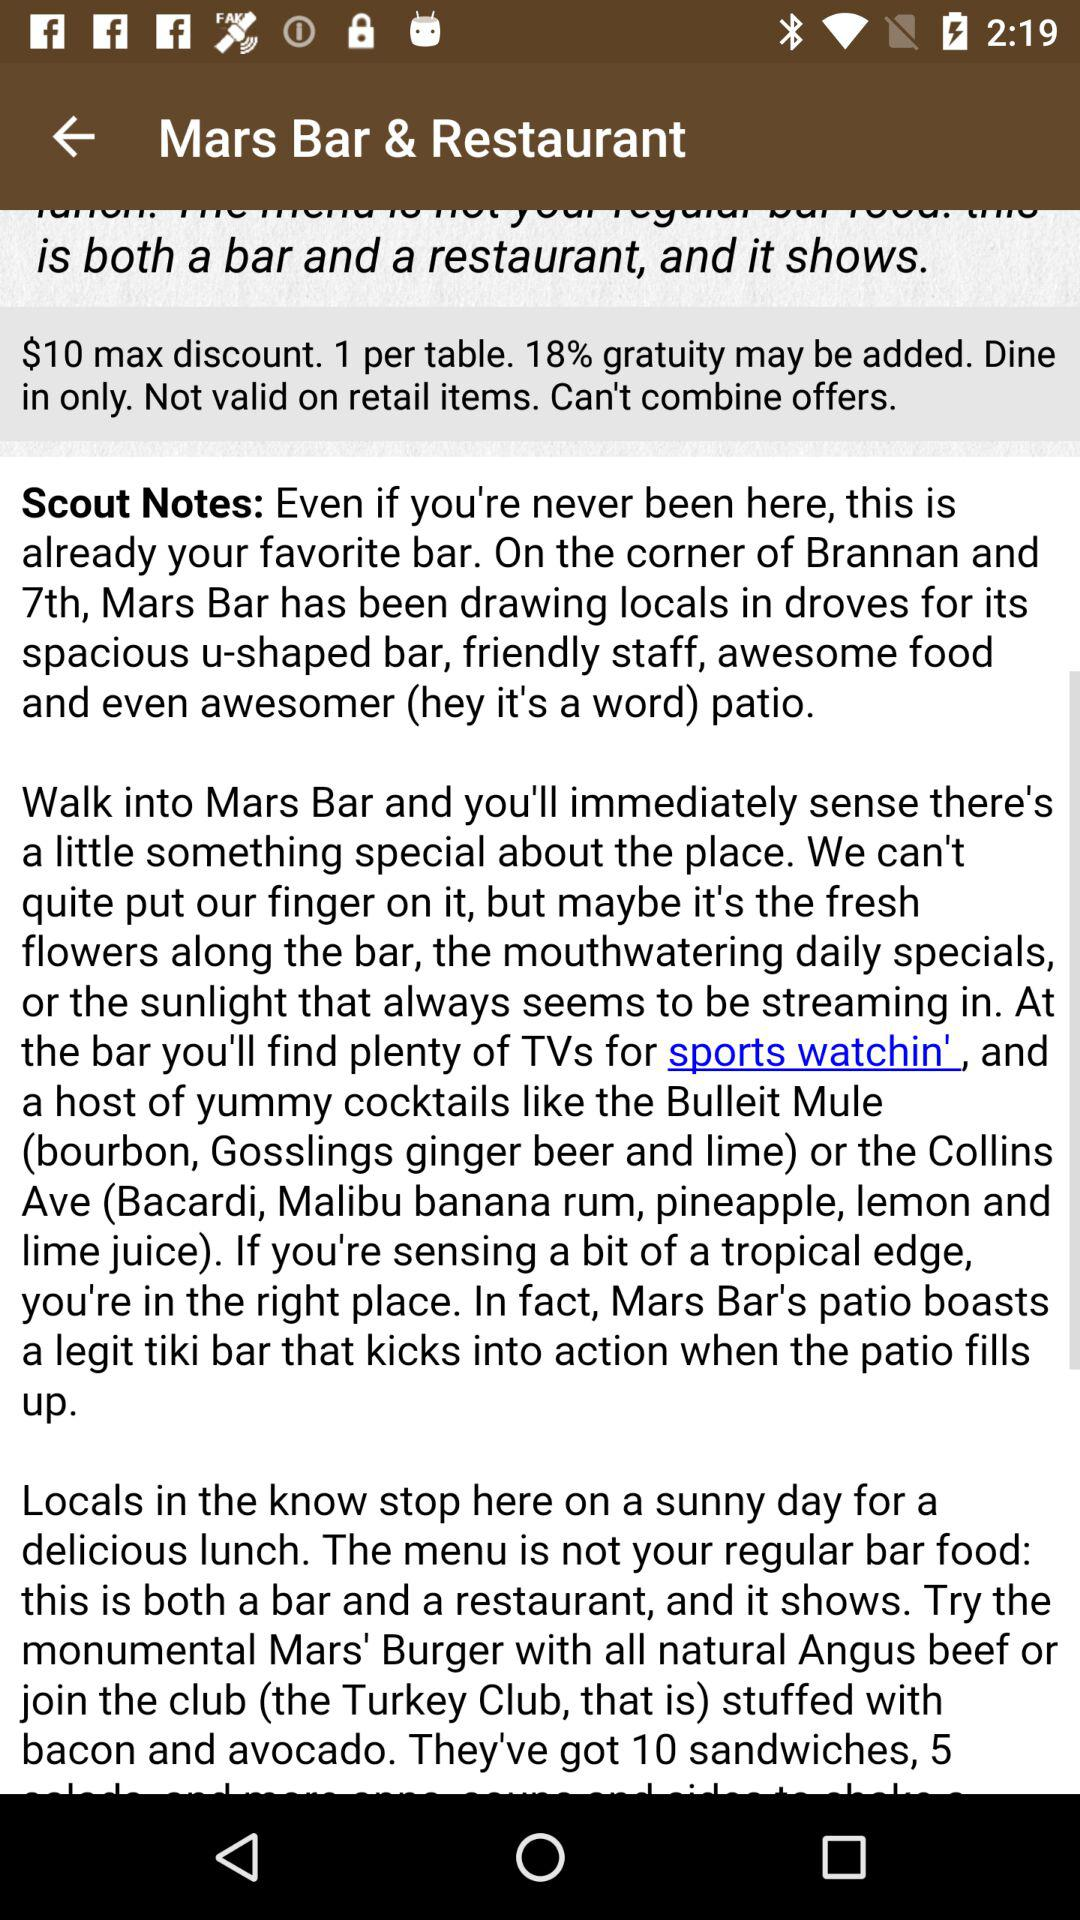What is the currency of the discount? The currency is dollars. 